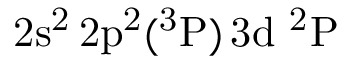<formula> <loc_0><loc_0><loc_500><loc_500>2 s ^ { 2 } \, 2 p ^ { 2 } ( ^ { 3 } P ) \, 3 d ^ { 2 } P</formula> 